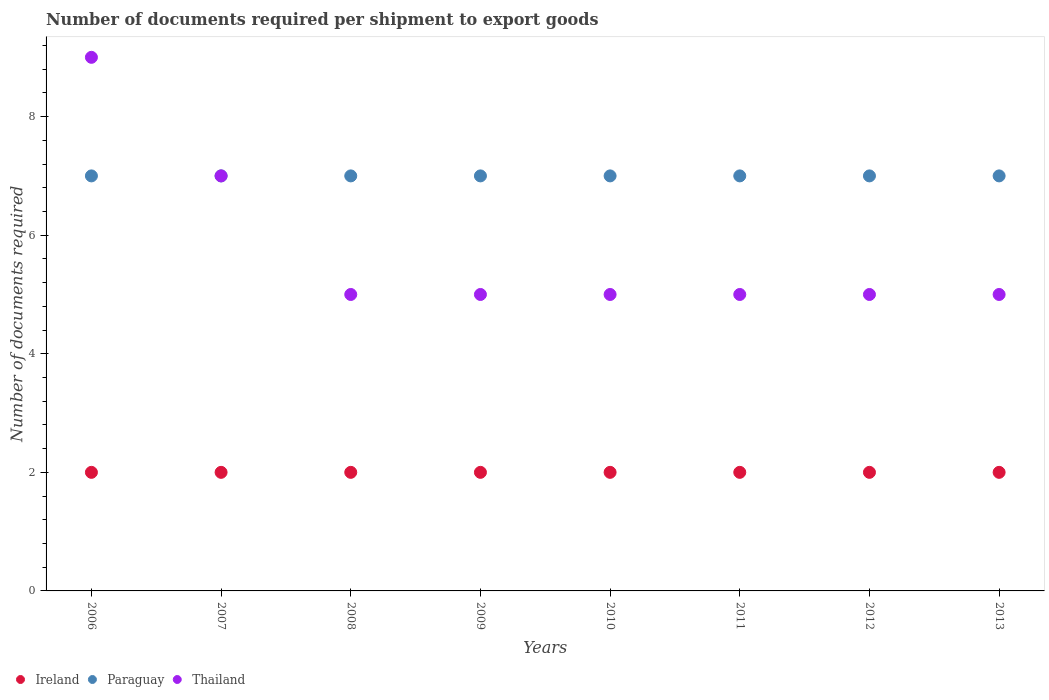Is the number of dotlines equal to the number of legend labels?
Your answer should be very brief. Yes. What is the number of documents required per shipment to export goods in Thailand in 2011?
Provide a succinct answer. 5. Across all years, what is the maximum number of documents required per shipment to export goods in Ireland?
Offer a very short reply. 2. Across all years, what is the minimum number of documents required per shipment to export goods in Thailand?
Your response must be concise. 5. What is the total number of documents required per shipment to export goods in Paraguay in the graph?
Your response must be concise. 56. What is the difference between the number of documents required per shipment to export goods in Thailand in 2009 and the number of documents required per shipment to export goods in Paraguay in 2012?
Your answer should be very brief. -2. What is the average number of documents required per shipment to export goods in Paraguay per year?
Offer a very short reply. 7. In the year 2011, what is the difference between the number of documents required per shipment to export goods in Thailand and number of documents required per shipment to export goods in Ireland?
Ensure brevity in your answer.  3. In how many years, is the number of documents required per shipment to export goods in Thailand greater than 5.6?
Give a very brief answer. 2. Is the number of documents required per shipment to export goods in Paraguay in 2007 less than that in 2012?
Your response must be concise. No. What is the difference between the highest and the second highest number of documents required per shipment to export goods in Ireland?
Your response must be concise. 0. In how many years, is the number of documents required per shipment to export goods in Ireland greater than the average number of documents required per shipment to export goods in Ireland taken over all years?
Make the answer very short. 0. Is the sum of the number of documents required per shipment to export goods in Thailand in 2009 and 2013 greater than the maximum number of documents required per shipment to export goods in Ireland across all years?
Your answer should be very brief. Yes. Is the number of documents required per shipment to export goods in Paraguay strictly less than the number of documents required per shipment to export goods in Thailand over the years?
Your answer should be very brief. No. How many dotlines are there?
Give a very brief answer. 3. How many years are there in the graph?
Provide a short and direct response. 8. Does the graph contain grids?
Offer a terse response. No. Where does the legend appear in the graph?
Keep it short and to the point. Bottom left. How are the legend labels stacked?
Keep it short and to the point. Horizontal. What is the title of the graph?
Offer a terse response. Number of documents required per shipment to export goods. What is the label or title of the Y-axis?
Your response must be concise. Number of documents required. What is the Number of documents required of Ireland in 2006?
Offer a very short reply. 2. What is the Number of documents required in Paraguay in 2007?
Provide a succinct answer. 7. What is the Number of documents required of Thailand in 2007?
Make the answer very short. 7. What is the Number of documents required in Paraguay in 2008?
Make the answer very short. 7. What is the Number of documents required of Paraguay in 2011?
Offer a very short reply. 7. What is the Number of documents required in Thailand in 2012?
Offer a terse response. 5. What is the Number of documents required in Paraguay in 2013?
Offer a terse response. 7. What is the Number of documents required of Thailand in 2013?
Give a very brief answer. 5. Across all years, what is the maximum Number of documents required in Ireland?
Your answer should be very brief. 2. Across all years, what is the maximum Number of documents required of Thailand?
Make the answer very short. 9. Across all years, what is the minimum Number of documents required in Ireland?
Keep it short and to the point. 2. Across all years, what is the minimum Number of documents required in Paraguay?
Keep it short and to the point. 7. Across all years, what is the minimum Number of documents required of Thailand?
Your answer should be very brief. 5. What is the total Number of documents required in Paraguay in the graph?
Provide a succinct answer. 56. What is the difference between the Number of documents required in Ireland in 2006 and that in 2007?
Your answer should be very brief. 0. What is the difference between the Number of documents required of Paraguay in 2006 and that in 2007?
Offer a terse response. 0. What is the difference between the Number of documents required of Ireland in 2006 and that in 2008?
Your answer should be very brief. 0. What is the difference between the Number of documents required in Ireland in 2006 and that in 2009?
Provide a succinct answer. 0. What is the difference between the Number of documents required in Ireland in 2006 and that in 2010?
Provide a short and direct response. 0. What is the difference between the Number of documents required in Paraguay in 2006 and that in 2010?
Make the answer very short. 0. What is the difference between the Number of documents required of Thailand in 2006 and that in 2010?
Your answer should be very brief. 4. What is the difference between the Number of documents required in Ireland in 2006 and that in 2011?
Provide a succinct answer. 0. What is the difference between the Number of documents required in Paraguay in 2006 and that in 2011?
Your answer should be very brief. 0. What is the difference between the Number of documents required in Paraguay in 2006 and that in 2012?
Ensure brevity in your answer.  0. What is the difference between the Number of documents required of Ireland in 2007 and that in 2008?
Your response must be concise. 0. What is the difference between the Number of documents required of Ireland in 2007 and that in 2009?
Offer a very short reply. 0. What is the difference between the Number of documents required of Paraguay in 2007 and that in 2009?
Your answer should be compact. 0. What is the difference between the Number of documents required of Ireland in 2007 and that in 2010?
Your answer should be compact. 0. What is the difference between the Number of documents required in Thailand in 2007 and that in 2010?
Make the answer very short. 2. What is the difference between the Number of documents required in Paraguay in 2007 and that in 2011?
Provide a succinct answer. 0. What is the difference between the Number of documents required in Paraguay in 2007 and that in 2012?
Provide a succinct answer. 0. What is the difference between the Number of documents required of Ireland in 2007 and that in 2013?
Provide a short and direct response. 0. What is the difference between the Number of documents required in Thailand in 2007 and that in 2013?
Provide a short and direct response. 2. What is the difference between the Number of documents required of Paraguay in 2008 and that in 2009?
Your response must be concise. 0. What is the difference between the Number of documents required in Thailand in 2008 and that in 2009?
Your answer should be very brief. 0. What is the difference between the Number of documents required in Ireland in 2008 and that in 2010?
Offer a terse response. 0. What is the difference between the Number of documents required in Thailand in 2008 and that in 2010?
Give a very brief answer. 0. What is the difference between the Number of documents required of Paraguay in 2008 and that in 2011?
Keep it short and to the point. 0. What is the difference between the Number of documents required in Thailand in 2008 and that in 2012?
Make the answer very short. 0. What is the difference between the Number of documents required of Paraguay in 2008 and that in 2013?
Offer a terse response. 0. What is the difference between the Number of documents required in Ireland in 2009 and that in 2010?
Keep it short and to the point. 0. What is the difference between the Number of documents required in Paraguay in 2009 and that in 2010?
Give a very brief answer. 0. What is the difference between the Number of documents required in Thailand in 2009 and that in 2010?
Give a very brief answer. 0. What is the difference between the Number of documents required in Ireland in 2009 and that in 2011?
Provide a short and direct response. 0. What is the difference between the Number of documents required in Paraguay in 2009 and that in 2011?
Offer a very short reply. 0. What is the difference between the Number of documents required in Thailand in 2009 and that in 2011?
Offer a terse response. 0. What is the difference between the Number of documents required in Ireland in 2009 and that in 2012?
Your response must be concise. 0. What is the difference between the Number of documents required of Paraguay in 2009 and that in 2012?
Offer a very short reply. 0. What is the difference between the Number of documents required of Thailand in 2009 and that in 2012?
Give a very brief answer. 0. What is the difference between the Number of documents required of Paraguay in 2009 and that in 2013?
Give a very brief answer. 0. What is the difference between the Number of documents required of Paraguay in 2010 and that in 2011?
Provide a succinct answer. 0. What is the difference between the Number of documents required of Ireland in 2010 and that in 2012?
Ensure brevity in your answer.  0. What is the difference between the Number of documents required of Paraguay in 2010 and that in 2012?
Offer a very short reply. 0. What is the difference between the Number of documents required of Thailand in 2010 and that in 2012?
Offer a terse response. 0. What is the difference between the Number of documents required in Paraguay in 2010 and that in 2013?
Your response must be concise. 0. What is the difference between the Number of documents required of Thailand in 2010 and that in 2013?
Provide a succinct answer. 0. What is the difference between the Number of documents required of Paraguay in 2011 and that in 2012?
Offer a very short reply. 0. What is the difference between the Number of documents required of Ireland in 2011 and that in 2013?
Ensure brevity in your answer.  0. What is the difference between the Number of documents required of Thailand in 2011 and that in 2013?
Offer a terse response. 0. What is the difference between the Number of documents required of Ireland in 2012 and that in 2013?
Provide a succinct answer. 0. What is the difference between the Number of documents required in Thailand in 2012 and that in 2013?
Offer a very short reply. 0. What is the difference between the Number of documents required in Ireland in 2006 and the Number of documents required in Thailand in 2007?
Your answer should be compact. -5. What is the difference between the Number of documents required of Paraguay in 2006 and the Number of documents required of Thailand in 2007?
Your answer should be compact. 0. What is the difference between the Number of documents required of Ireland in 2006 and the Number of documents required of Thailand in 2008?
Your answer should be very brief. -3. What is the difference between the Number of documents required in Ireland in 2006 and the Number of documents required in Thailand in 2010?
Provide a short and direct response. -3. What is the difference between the Number of documents required of Paraguay in 2006 and the Number of documents required of Thailand in 2010?
Your answer should be very brief. 2. What is the difference between the Number of documents required of Paraguay in 2006 and the Number of documents required of Thailand in 2012?
Ensure brevity in your answer.  2. What is the difference between the Number of documents required of Paraguay in 2006 and the Number of documents required of Thailand in 2013?
Give a very brief answer. 2. What is the difference between the Number of documents required in Ireland in 2007 and the Number of documents required in Thailand in 2008?
Your response must be concise. -3. What is the difference between the Number of documents required in Ireland in 2007 and the Number of documents required in Thailand in 2010?
Give a very brief answer. -3. What is the difference between the Number of documents required of Paraguay in 2007 and the Number of documents required of Thailand in 2010?
Offer a terse response. 2. What is the difference between the Number of documents required of Ireland in 2007 and the Number of documents required of Paraguay in 2011?
Give a very brief answer. -5. What is the difference between the Number of documents required in Paraguay in 2007 and the Number of documents required in Thailand in 2011?
Keep it short and to the point. 2. What is the difference between the Number of documents required in Paraguay in 2007 and the Number of documents required in Thailand in 2013?
Your response must be concise. 2. What is the difference between the Number of documents required of Ireland in 2008 and the Number of documents required of Thailand in 2009?
Offer a very short reply. -3. What is the difference between the Number of documents required in Paraguay in 2008 and the Number of documents required in Thailand in 2009?
Your answer should be very brief. 2. What is the difference between the Number of documents required in Ireland in 2008 and the Number of documents required in Thailand in 2011?
Make the answer very short. -3. What is the difference between the Number of documents required of Ireland in 2008 and the Number of documents required of Paraguay in 2012?
Your answer should be very brief. -5. What is the difference between the Number of documents required of Ireland in 2008 and the Number of documents required of Thailand in 2012?
Your response must be concise. -3. What is the difference between the Number of documents required in Paraguay in 2008 and the Number of documents required in Thailand in 2012?
Provide a succinct answer. 2. What is the difference between the Number of documents required of Ireland in 2008 and the Number of documents required of Paraguay in 2013?
Give a very brief answer. -5. What is the difference between the Number of documents required of Ireland in 2009 and the Number of documents required of Paraguay in 2011?
Offer a terse response. -5. What is the difference between the Number of documents required in Paraguay in 2009 and the Number of documents required in Thailand in 2011?
Your answer should be compact. 2. What is the difference between the Number of documents required of Ireland in 2009 and the Number of documents required of Paraguay in 2012?
Provide a succinct answer. -5. What is the difference between the Number of documents required in Ireland in 2009 and the Number of documents required in Paraguay in 2013?
Offer a terse response. -5. What is the difference between the Number of documents required in Ireland in 2010 and the Number of documents required in Thailand in 2011?
Give a very brief answer. -3. What is the difference between the Number of documents required in Paraguay in 2010 and the Number of documents required in Thailand in 2011?
Keep it short and to the point. 2. What is the difference between the Number of documents required in Ireland in 2010 and the Number of documents required in Paraguay in 2012?
Keep it short and to the point. -5. What is the difference between the Number of documents required in Ireland in 2010 and the Number of documents required in Paraguay in 2013?
Ensure brevity in your answer.  -5. What is the difference between the Number of documents required in Ireland in 2010 and the Number of documents required in Thailand in 2013?
Your answer should be compact. -3. What is the difference between the Number of documents required in Paraguay in 2010 and the Number of documents required in Thailand in 2013?
Keep it short and to the point. 2. What is the difference between the Number of documents required in Ireland in 2011 and the Number of documents required in Paraguay in 2012?
Offer a terse response. -5. What is the difference between the Number of documents required in Paraguay in 2011 and the Number of documents required in Thailand in 2012?
Your response must be concise. 2. What is the difference between the Number of documents required in Ireland in 2011 and the Number of documents required in Paraguay in 2013?
Provide a short and direct response. -5. What is the difference between the Number of documents required in Paraguay in 2011 and the Number of documents required in Thailand in 2013?
Ensure brevity in your answer.  2. What is the difference between the Number of documents required of Ireland in 2012 and the Number of documents required of Paraguay in 2013?
Keep it short and to the point. -5. What is the average Number of documents required of Paraguay per year?
Give a very brief answer. 7. What is the average Number of documents required in Thailand per year?
Offer a very short reply. 5.75. In the year 2006, what is the difference between the Number of documents required in Ireland and Number of documents required in Paraguay?
Offer a terse response. -5. In the year 2006, what is the difference between the Number of documents required of Ireland and Number of documents required of Thailand?
Give a very brief answer. -7. In the year 2006, what is the difference between the Number of documents required of Paraguay and Number of documents required of Thailand?
Ensure brevity in your answer.  -2. In the year 2007, what is the difference between the Number of documents required of Ireland and Number of documents required of Thailand?
Provide a short and direct response. -5. In the year 2008, what is the difference between the Number of documents required of Ireland and Number of documents required of Paraguay?
Your response must be concise. -5. In the year 2009, what is the difference between the Number of documents required in Ireland and Number of documents required in Paraguay?
Your response must be concise. -5. In the year 2009, what is the difference between the Number of documents required of Ireland and Number of documents required of Thailand?
Your answer should be very brief. -3. In the year 2009, what is the difference between the Number of documents required of Paraguay and Number of documents required of Thailand?
Provide a short and direct response. 2. In the year 2010, what is the difference between the Number of documents required of Ireland and Number of documents required of Paraguay?
Make the answer very short. -5. In the year 2011, what is the difference between the Number of documents required of Ireland and Number of documents required of Paraguay?
Your answer should be very brief. -5. In the year 2011, what is the difference between the Number of documents required of Paraguay and Number of documents required of Thailand?
Keep it short and to the point. 2. In the year 2012, what is the difference between the Number of documents required in Paraguay and Number of documents required in Thailand?
Make the answer very short. 2. In the year 2013, what is the difference between the Number of documents required of Ireland and Number of documents required of Thailand?
Keep it short and to the point. -3. In the year 2013, what is the difference between the Number of documents required in Paraguay and Number of documents required in Thailand?
Make the answer very short. 2. What is the ratio of the Number of documents required in Paraguay in 2006 to that in 2007?
Keep it short and to the point. 1. What is the ratio of the Number of documents required of Paraguay in 2006 to that in 2008?
Provide a short and direct response. 1. What is the ratio of the Number of documents required in Ireland in 2006 to that in 2009?
Your answer should be compact. 1. What is the ratio of the Number of documents required in Thailand in 2006 to that in 2009?
Your answer should be very brief. 1.8. What is the ratio of the Number of documents required in Thailand in 2006 to that in 2010?
Provide a short and direct response. 1.8. What is the ratio of the Number of documents required of Ireland in 2006 to that in 2011?
Keep it short and to the point. 1. What is the ratio of the Number of documents required of Thailand in 2006 to that in 2011?
Your response must be concise. 1.8. What is the ratio of the Number of documents required in Thailand in 2006 to that in 2013?
Offer a terse response. 1.8. What is the ratio of the Number of documents required in Paraguay in 2007 to that in 2008?
Offer a very short reply. 1. What is the ratio of the Number of documents required in Thailand in 2007 to that in 2008?
Offer a terse response. 1.4. What is the ratio of the Number of documents required in Ireland in 2007 to that in 2009?
Keep it short and to the point. 1. What is the ratio of the Number of documents required in Paraguay in 2007 to that in 2009?
Keep it short and to the point. 1. What is the ratio of the Number of documents required in Thailand in 2007 to that in 2009?
Offer a very short reply. 1.4. What is the ratio of the Number of documents required in Ireland in 2007 to that in 2010?
Make the answer very short. 1. What is the ratio of the Number of documents required of Thailand in 2007 to that in 2010?
Provide a short and direct response. 1.4. What is the ratio of the Number of documents required of Paraguay in 2007 to that in 2011?
Give a very brief answer. 1. What is the ratio of the Number of documents required of Thailand in 2007 to that in 2011?
Provide a succinct answer. 1.4. What is the ratio of the Number of documents required of Paraguay in 2007 to that in 2012?
Make the answer very short. 1. What is the ratio of the Number of documents required of Ireland in 2008 to that in 2009?
Ensure brevity in your answer.  1. What is the ratio of the Number of documents required of Paraguay in 2008 to that in 2009?
Your answer should be very brief. 1. What is the ratio of the Number of documents required in Thailand in 2008 to that in 2009?
Keep it short and to the point. 1. What is the ratio of the Number of documents required in Ireland in 2008 to that in 2011?
Offer a very short reply. 1. What is the ratio of the Number of documents required of Ireland in 2008 to that in 2012?
Make the answer very short. 1. What is the ratio of the Number of documents required in Paraguay in 2008 to that in 2012?
Offer a terse response. 1. What is the ratio of the Number of documents required of Paraguay in 2009 to that in 2010?
Make the answer very short. 1. What is the ratio of the Number of documents required in Thailand in 2009 to that in 2010?
Your answer should be very brief. 1. What is the ratio of the Number of documents required in Ireland in 2010 to that in 2011?
Offer a very short reply. 1. What is the ratio of the Number of documents required of Paraguay in 2010 to that in 2011?
Make the answer very short. 1. What is the ratio of the Number of documents required in Thailand in 2010 to that in 2011?
Your answer should be compact. 1. What is the ratio of the Number of documents required in Ireland in 2010 to that in 2012?
Your answer should be compact. 1. What is the ratio of the Number of documents required of Paraguay in 2010 to that in 2012?
Offer a very short reply. 1. What is the ratio of the Number of documents required of Thailand in 2010 to that in 2012?
Your response must be concise. 1. What is the ratio of the Number of documents required in Ireland in 2011 to that in 2012?
Your answer should be compact. 1. What is the ratio of the Number of documents required in Paraguay in 2011 to that in 2012?
Your response must be concise. 1. What is the ratio of the Number of documents required in Ireland in 2011 to that in 2013?
Your answer should be compact. 1. What is the ratio of the Number of documents required of Thailand in 2011 to that in 2013?
Your response must be concise. 1. What is the ratio of the Number of documents required of Ireland in 2012 to that in 2013?
Your answer should be very brief. 1. What is the difference between the highest and the second highest Number of documents required of Paraguay?
Keep it short and to the point. 0. What is the difference between the highest and the second highest Number of documents required in Thailand?
Offer a very short reply. 2. What is the difference between the highest and the lowest Number of documents required of Ireland?
Provide a short and direct response. 0. What is the difference between the highest and the lowest Number of documents required of Thailand?
Your answer should be very brief. 4. 